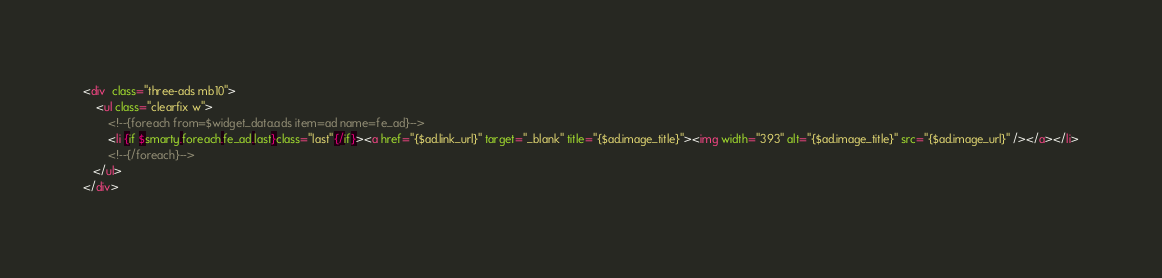Convert code to text. <code><loc_0><loc_0><loc_500><loc_500><_HTML_><div  class="three-ads mb10">
    <ul class="clearfix w">
        <!--{foreach from=$widget_data.ads item=ad name=fe_ad}-->
    	<li {if $smarty.foreach.fe_ad.last}class="last"{/if}><a href="{$ad.link_url}" target="_blank" title="{$ad.image_title}"><img width="393" alt="{$ad.image_title}" src="{$ad.image_url}" /></a></li>
    	<!--{/foreach}-->
   </ul>
</div>
</code> 